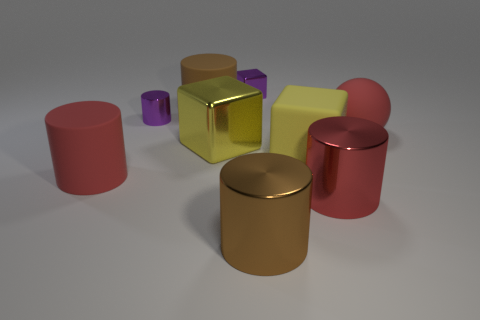Subtract all purple metallic blocks. How many blocks are left? 2 Subtract all brown cylinders. How many cylinders are left? 3 Subtract all spheres. How many objects are left? 8 Subtract all red balls. How many red cylinders are left? 2 Add 1 big red shiny cylinders. How many big red shiny cylinders are left? 2 Add 8 tiny purple things. How many tiny purple things exist? 10 Add 1 large green shiny things. How many objects exist? 10 Subtract 0 green blocks. How many objects are left? 9 Subtract all blue cylinders. Subtract all gray balls. How many cylinders are left? 5 Subtract all large matte spheres. Subtract all brown things. How many objects are left? 6 